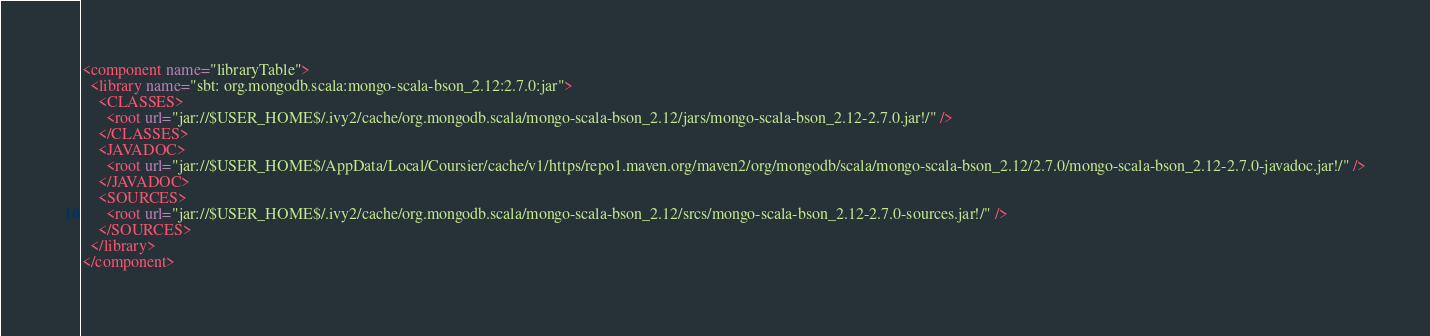Convert code to text. <code><loc_0><loc_0><loc_500><loc_500><_XML_><component name="libraryTable">
  <library name="sbt: org.mongodb.scala:mongo-scala-bson_2.12:2.7.0:jar">
    <CLASSES>
      <root url="jar://$USER_HOME$/.ivy2/cache/org.mongodb.scala/mongo-scala-bson_2.12/jars/mongo-scala-bson_2.12-2.7.0.jar!/" />
    </CLASSES>
    <JAVADOC>
      <root url="jar://$USER_HOME$/AppData/Local/Coursier/cache/v1/https/repo1.maven.org/maven2/org/mongodb/scala/mongo-scala-bson_2.12/2.7.0/mongo-scala-bson_2.12-2.7.0-javadoc.jar!/" />
    </JAVADOC>
    <SOURCES>
      <root url="jar://$USER_HOME$/.ivy2/cache/org.mongodb.scala/mongo-scala-bson_2.12/srcs/mongo-scala-bson_2.12-2.7.0-sources.jar!/" />
    </SOURCES>
  </library>
</component></code> 